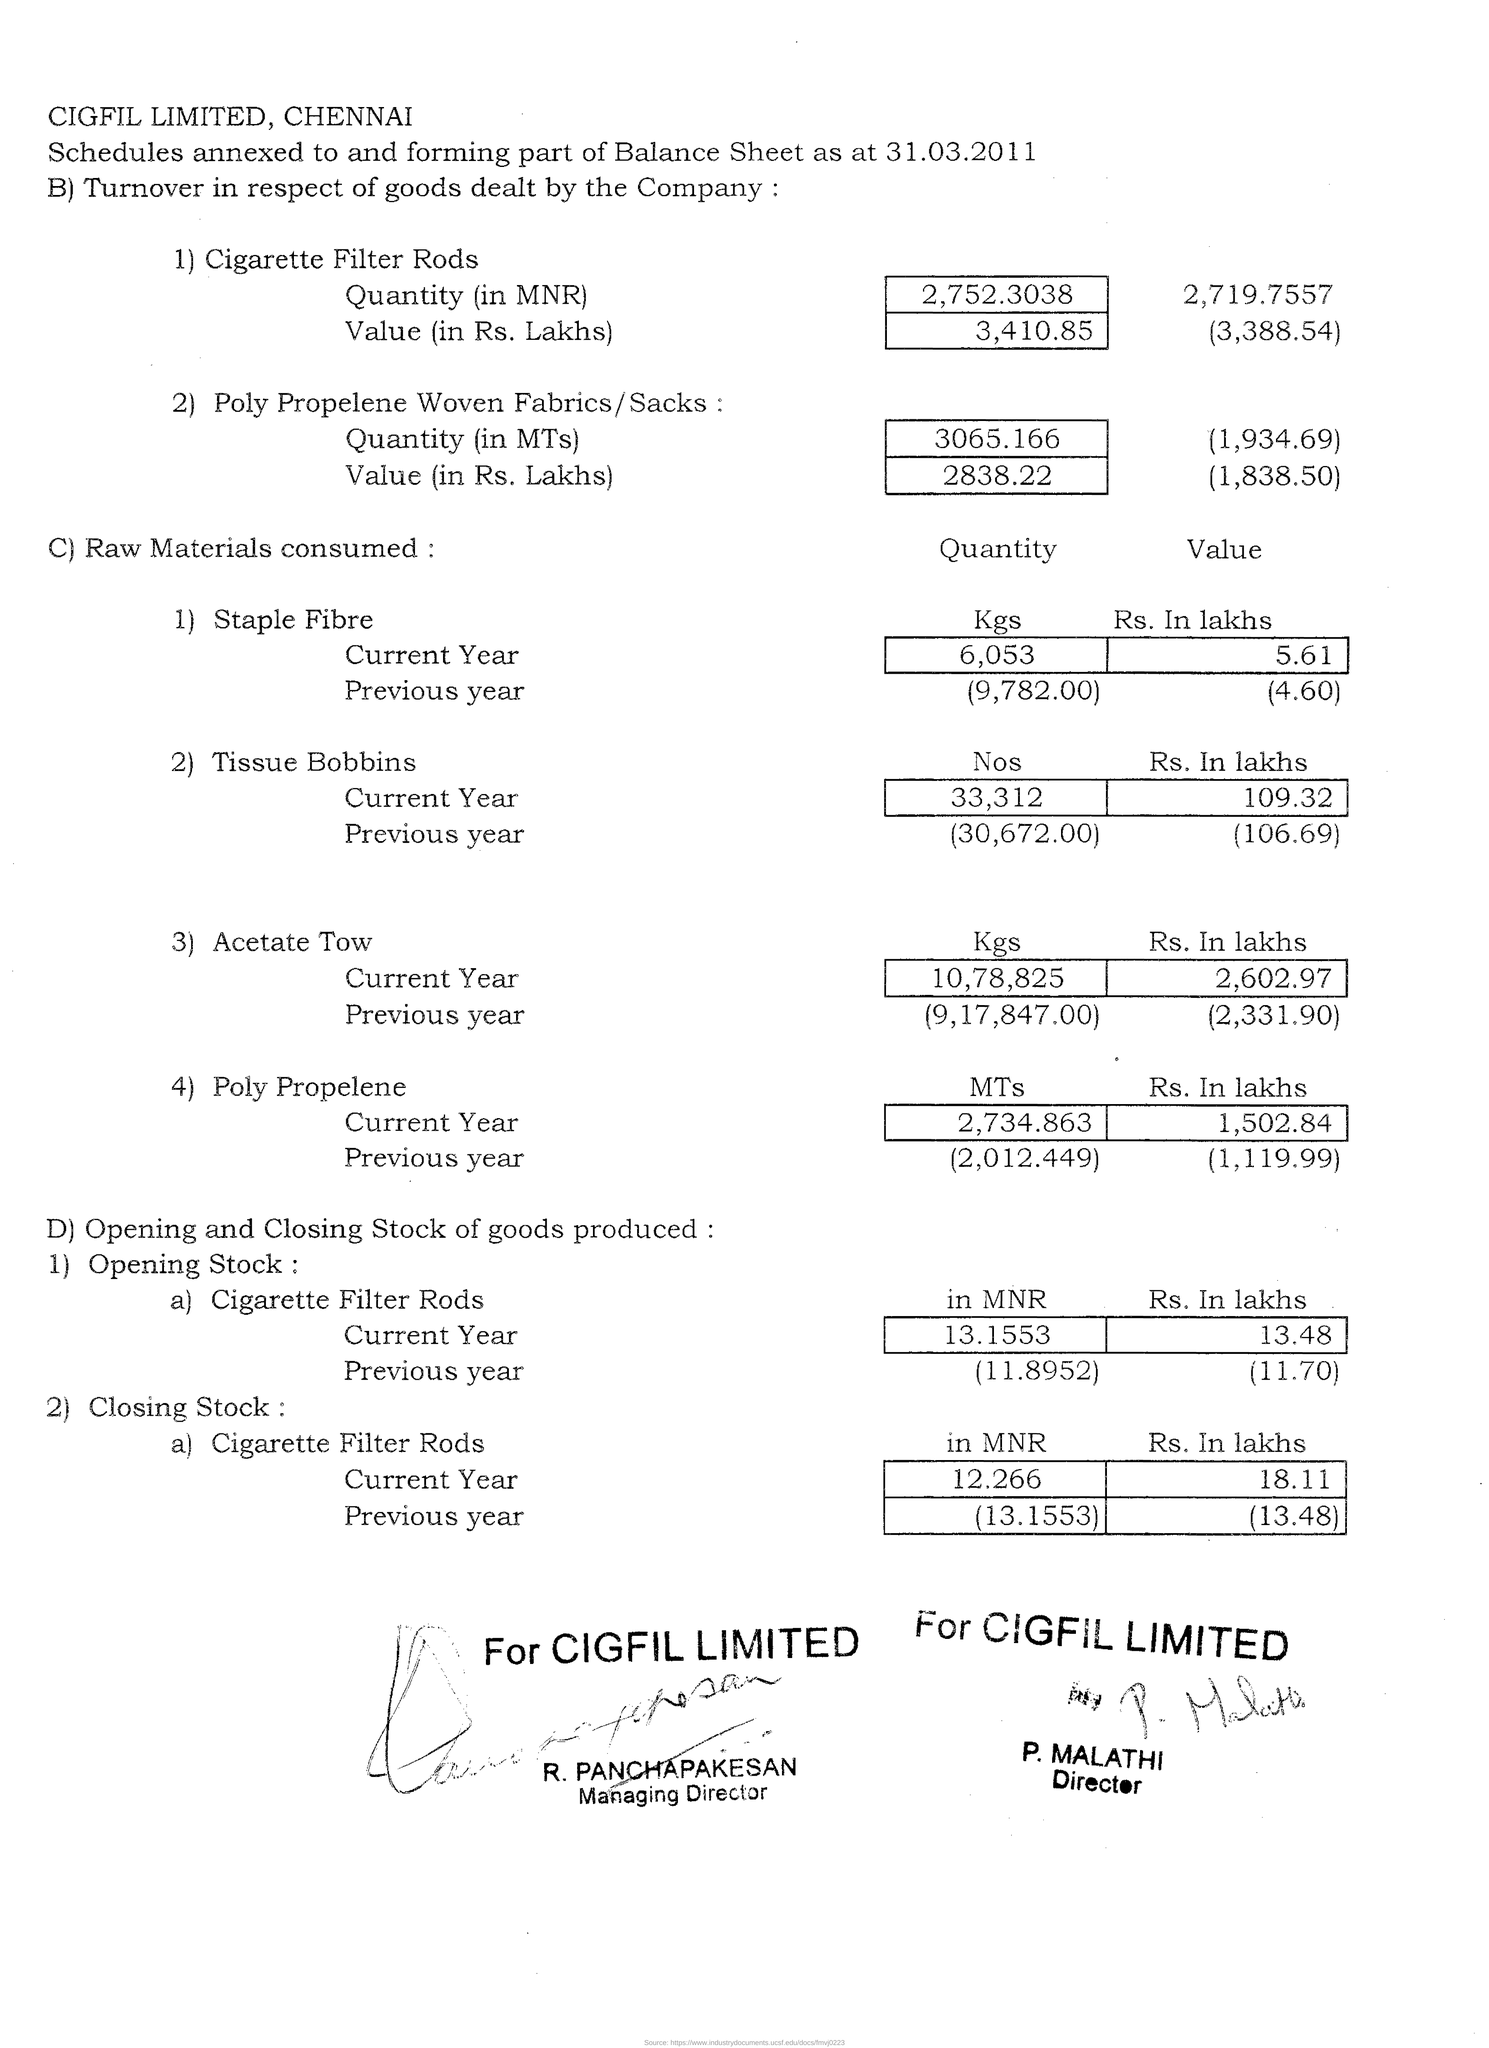List a handful of essential elements in this visual. The opening stock of cigarette filter rods in the previous year in MNR was 11.8952... As of my knowledge cutoff date, P. Malathi's designation was Director. The company name provided is CIGFIL LIMITED, located in Chennai. The quantity of Poly Propelene consumed in the previous year was 2,012,449 metric tons. Approximately 6,053 kilograms of staple fiber was consumed in the current year. 